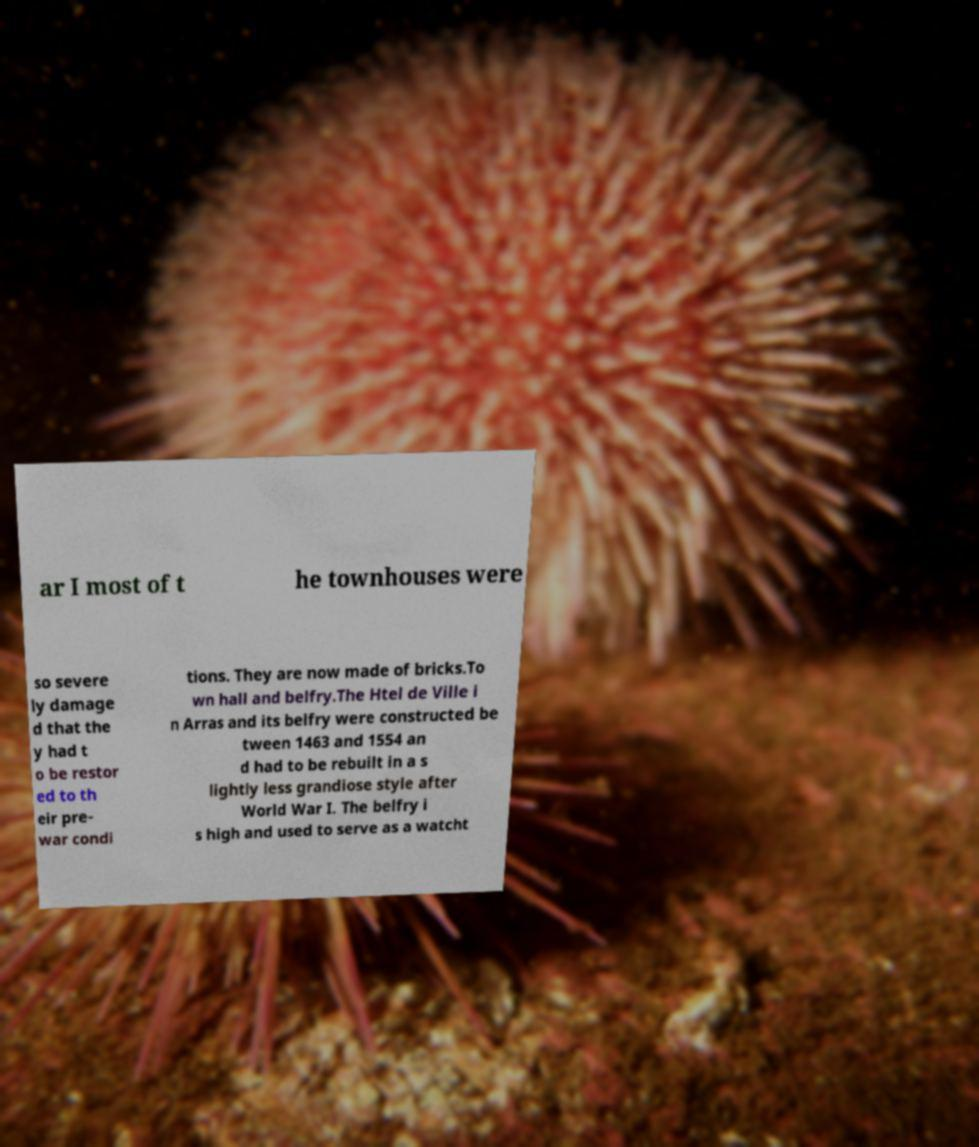What messages or text are displayed in this image? I need them in a readable, typed format. ar I most of t he townhouses were so severe ly damage d that the y had t o be restor ed to th eir pre- war condi tions. They are now made of bricks.To wn hall and belfry.The Htel de Ville i n Arras and its belfry were constructed be tween 1463 and 1554 an d had to be rebuilt in a s lightly less grandiose style after World War I. The belfry i s high and used to serve as a watcht 